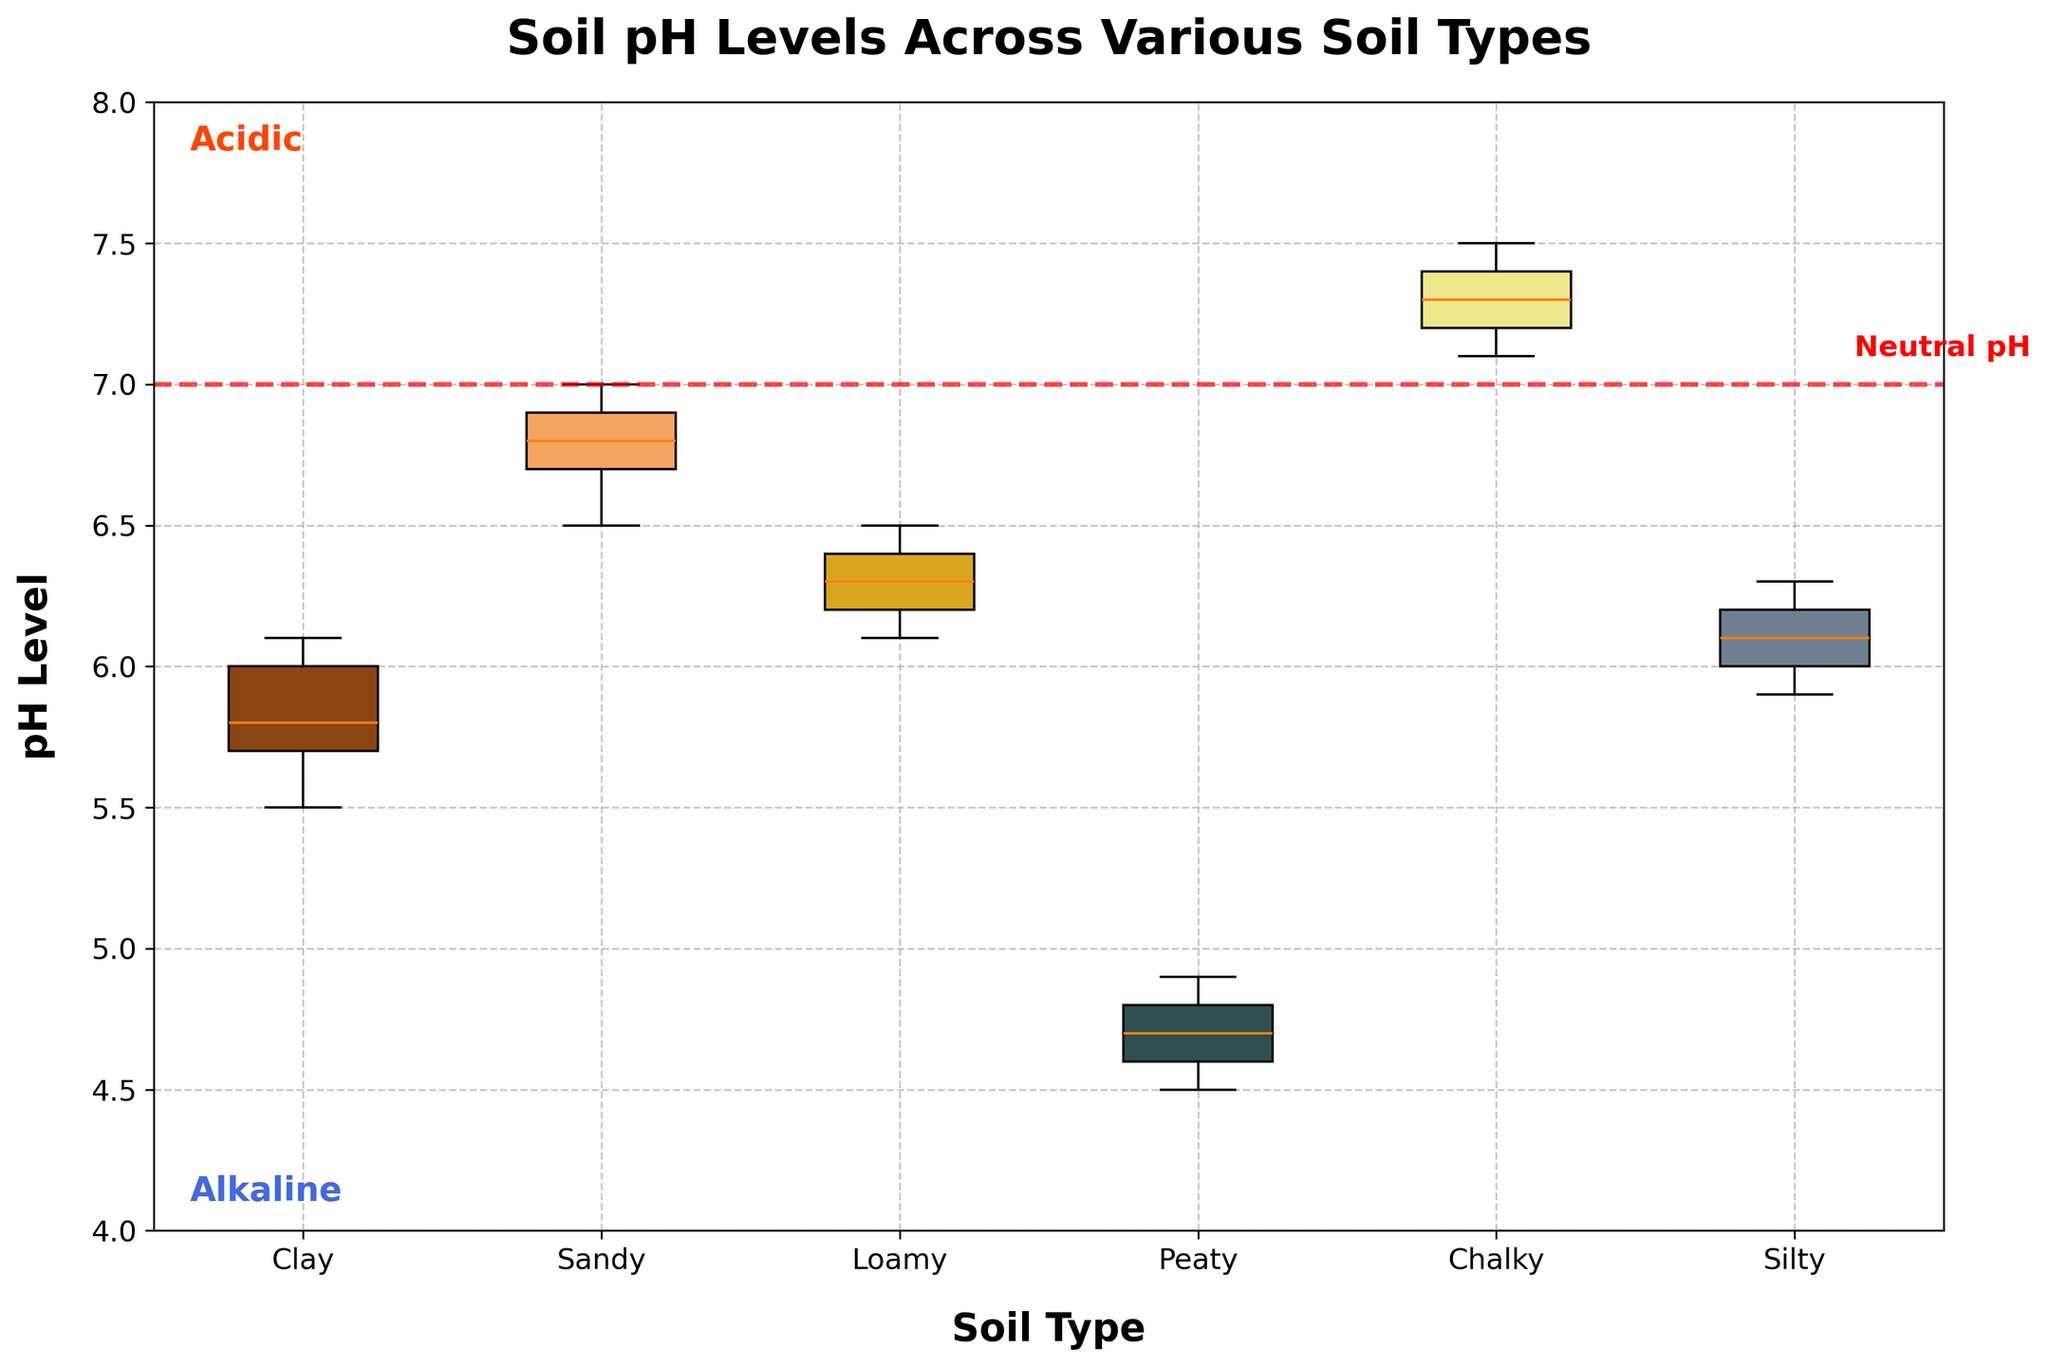Which soil type has the highest median pH level? To determine the soil type with the highest median pH level, look at the horizontal line within each box representing the median. The Chalky soil has the highest median value.
Answer: Chalky What is the range of pH levels for Peaty soil? The range is calculated by subtracting the lowest pH value from the highest pH value in the box plot for Peaty soil. The highest value is around 4.9, and the lowest value is around 4.5. Subtracting these gives 4.9 - 4.5.
Answer: 0.4 Which soil type shows the greatest variation in pH levels? Variation can be assessed by looking at the length of the boxes and whiskers. The longer the combined length, the greater the variation. Among all soil types, Sandy shows the greatest variation since its box and whiskers span the widest range.
Answer: Sandy Are any soil types consistently alkaline or acidic based on their pH levels? Soil types with pH levels consistently above 7.0 are alkaline, while those consistently below 7.0 are acidic. Chalky is consistently above 7.0 (alkaline), and Peaty is consistently below 7.0 (acidic).
Answer: Chalky (alkaline), Peaty (acidic) How does the median pH level of Clay soil compare to Sandy soil? By looking at the horizontal lines within the boxes of Clay and Sandy soils, the median of Clay soil appears around 5.8, while the median of Sandy soil is around 6.8. Therefore, Sandy soil's median pH is higher than that of Clay soil.
Answer: Sandy soil's median is higher What's the interquartile range (IQR) for Loamy soil? IQR is the difference between the upper quartile (Q3) and the lower quartile (Q1). From the Loamy soil box plot, Q3 is roughly 6.4, and Q1 is roughly 6.2, so the IQR is 6.4 - 6.2.
Answer: 0.2 Which soil type has pH values closest to neutral pH (7.0) most consistently? Closest to the neutral pH line (7.0) is determined by the horizontal proximity of the box and whiskers. Sandy and Silty soils are closer to 7.0, but parts of Sandy soil are nearer to this line.
Answer: Sandy What's the span of the whiskers for Silty soil? The span of the whiskers is determined by the highest and lowest data points (excluding outliers). For Silty soil, the highest value is around 6.3, and the lowest is around 5.9, giving a whisker span of 6.3 - 5.9.
Answer: 0.4 Is the median pH of any soil types exactly at the neutral pH? By looking at the horizontal lines within the boxes relative to the neutral pH line at 7.0, we can see that none of the soil types have a median pH exactly at 7.0.
Answer: No 